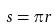<formula> <loc_0><loc_0><loc_500><loc_500>s = \pi r</formula> 